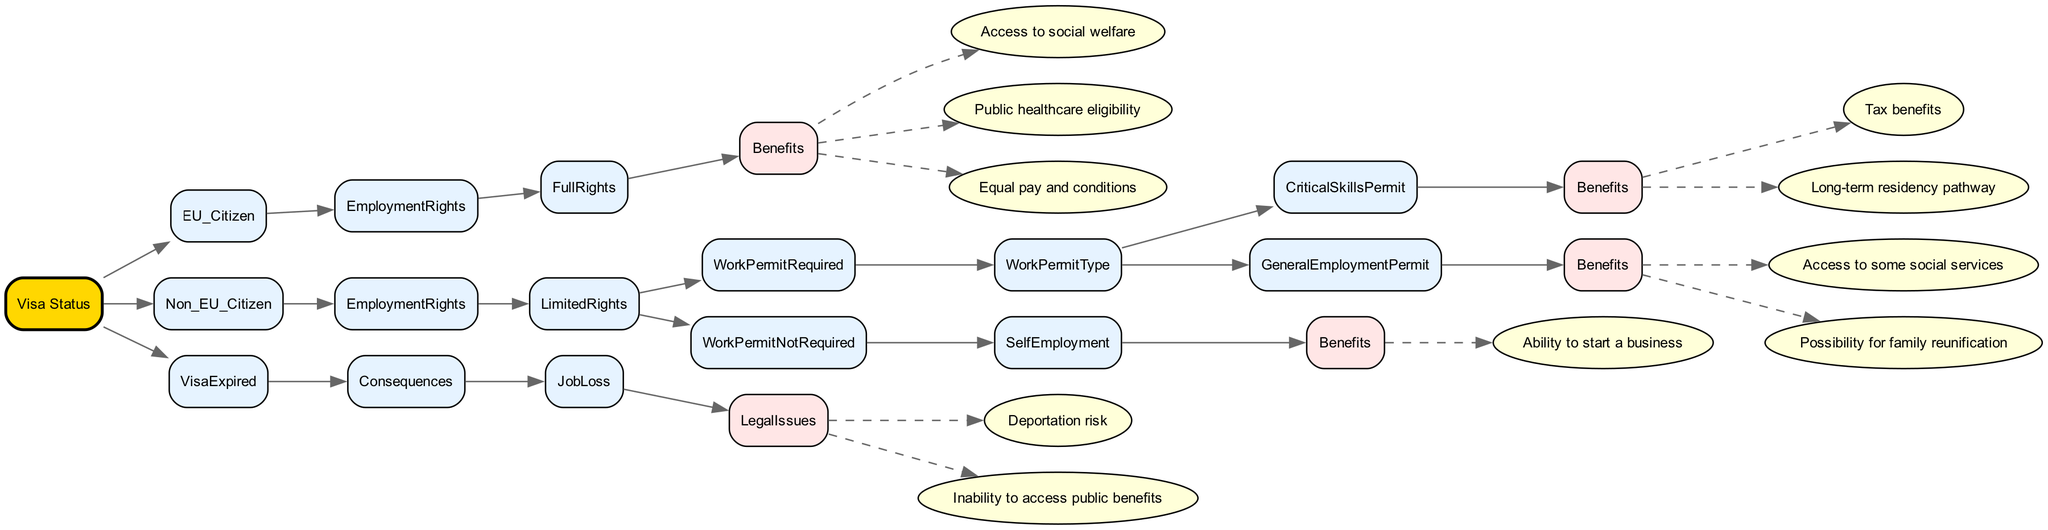What are the employment rights for EU citizens? The diagram states that EU citizens have "Full Rights" in terms of employment. This indicates no limitations on their rights to work, which can be inferred from the structure of the tree, leading to the benefits listed under "FullRights."
Answer: Full Rights What benefits do Non-EU citizens with a Critical Skills Permit receive? The diagram indicates that Non-EU citizens with a Critical Skills Permit receive "Tax benefits" and a "Long-term residency pathway." These benefits were detailed under the "WorkPermitType" node for Critical Skills Permit.
Answer: Tax benefits, Long-term residency pathway How many benefits do Non-EU citizens with a General Employment Permit have? Looking under the "GeneralEmploymentPermit" node, there are two benefits listed: "Access to some social services" and "Possibility for family reunification," leading to a total count of two benefits.
Answer: 2 What is the consequence of having an expired visa? The diagram clearly shows that having an expired visa leads to "Job Loss," which is a direct consequence displayed in the "VisaExpired" section of the tree.
Answer: Job Loss Do Non-EU citizens need a work permit for self-employment? The diagram specifies that Non-EU citizens who are self-employed do not require a work permit, as indicated in the "WorkPermitNotRequired" branch.
Answer: No What are the legal issues faced by individuals with an expired visa? Under the "JobLoss" consequence for expired visas, the diagram lists "Deportation risk" and "Inability to access public benefits," detailing the legal issues they might encounter.
Answer: Deportation risk, Inability to access public benefits Which category has access to public healthcare eligibility? The diagram indicates that EU citizens under "FullRights" are the ones who have access to public healthcare eligibility, confirming the benefits linked with their status.
Answer: EU citizens What is required for Non-EU citizens to have limited employment rights? The diagram shows that to have limited employment rights, Non-EU citizens must require a "WorkPermit," which is indicated in the "LimitedRights" section of the diagram.
Answer: Work Permit How many total categories are there under Visa Status? The diagram provides three main categories: "EU_Citizen," "Non_EU_Citizen," and "VisaExpired", thus totaling three categories under the "Visa Status" root node.
Answer: 3 